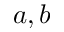Convert formula to latex. <formula><loc_0><loc_0><loc_500><loc_500>a , b</formula> 